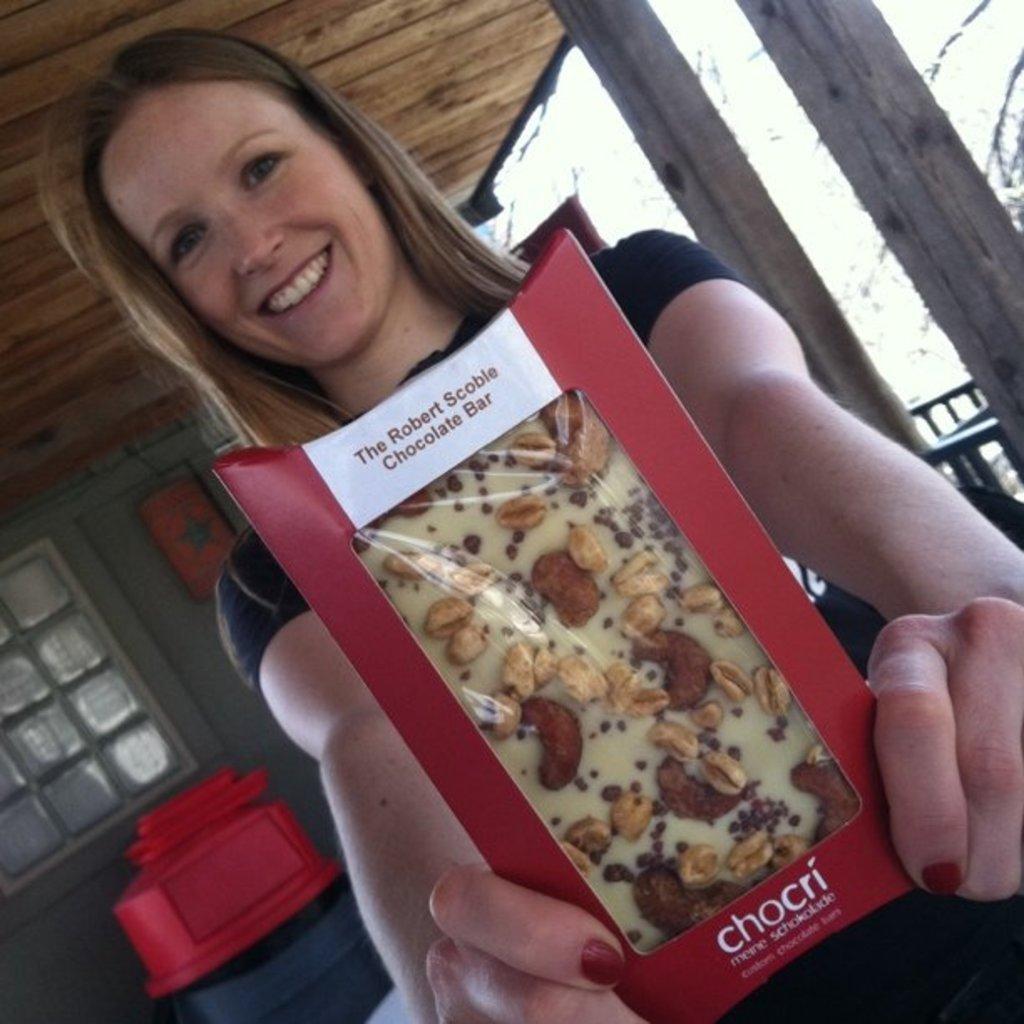Describe this image in one or two sentences. In this image we can see a woman smiling and holding a packet, there are pillars, grille and a window, also we can see some objects, at the top we can see some wooden poles and also we can see the sky. 